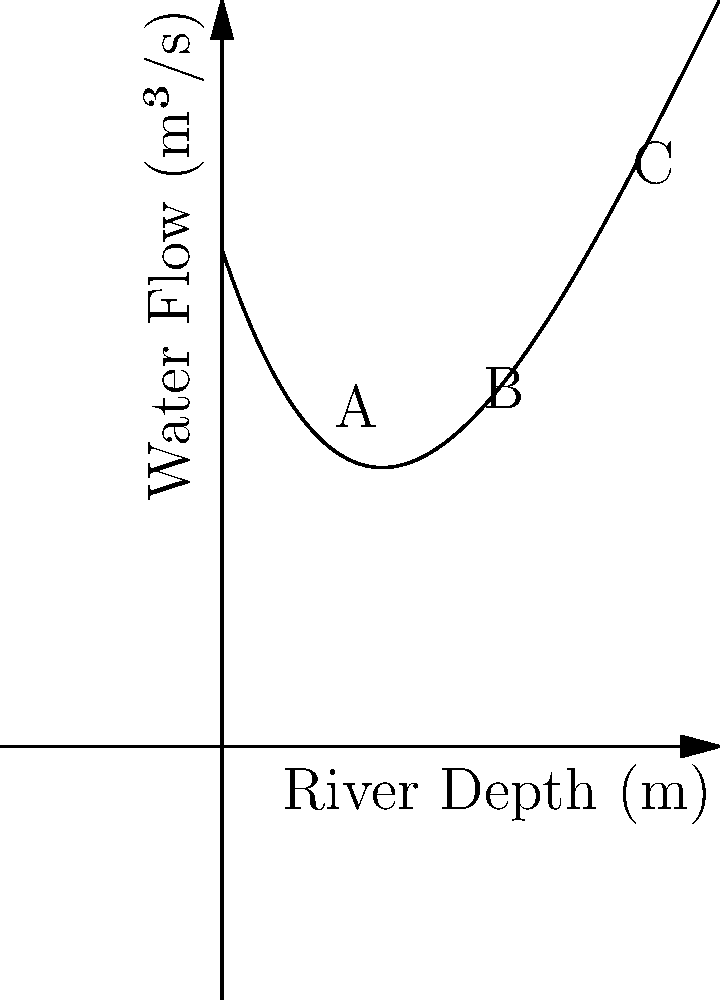The graph represents the relationship between river depth and water flow for the historic Meander River, known for its winding course that gave rise to the term "meander" in geography. The relationship is modeled by a quartic polynomial: $f(x) = 0.0005x^4 - 0.03x^3 + 0.6x^2 - 3x + 10$, where $x$ is the river depth in meters and $f(x)$ is the water flow in cubic meters per second. At which point (A, B, or C) does the river exhibit the highest flow rate, and what might this reveal about the river's history and impact on local ecosystems? To determine the point with the highest flow rate, we need to compare the y-values (water flow) at points A, B, and C:

1. Point A is at x = 2m depth:
   $f(2) = 0.0005(2^4) - 0.03(2^3) + 0.6(2^2) - 3(2) + 10 = 4.32$ m³/s

2. Point B is at x = 5m depth:
   $f(5) = 0.0005(5^4) - 0.03(5^3) + 0.6(5^2) - 3(5) + 10 = 11.875$ m³/s

3. Point C is at x = 8m depth:
   $f(8) = 0.0005(8^4) - 0.03(8^3) + 0.6(8^2) - 3(8) + 10 = 46.24$ m³/s

Point C has the highest flow rate at 46.24 m³/s.

This reveals that the Meander River's flow rate increases significantly with depth, particularly in deeper sections. Historically, this could indicate:

1. The river has carved a deeper channel over time, allowing for higher flow rates.
2. Deeper sections may have been crucial for ancient civilizations, providing more water for irrigation and transportation.
3. The varying flow rates at different depths could support diverse ecosystems, with different species adapted to specific depth ranges.
4. The high flow rate at greater depths might explain the river's meandering nature, as the increased water volume and speed could contribute to more erosion and deposition, shaping the characteristic bends.
Answer: Point C; highest flow indicates deep, carved channel supporting diverse ecosystems and influencing meandering pattern. 